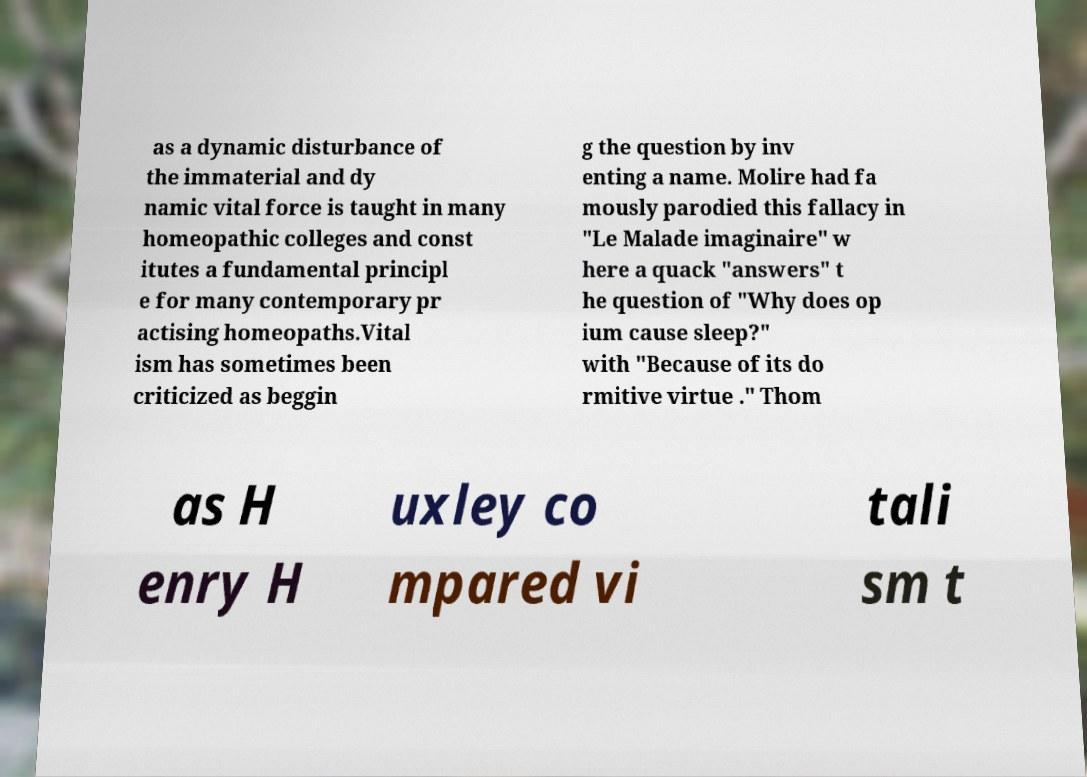Could you extract and type out the text from this image? as a dynamic disturbance of the immaterial and dy namic vital force is taught in many homeopathic colleges and const itutes a fundamental principl e for many contemporary pr actising homeopaths.Vital ism has sometimes been criticized as beggin g the question by inv enting a name. Molire had fa mously parodied this fallacy in "Le Malade imaginaire" w here a quack "answers" t he question of "Why does op ium cause sleep?" with "Because of its do rmitive virtue ." Thom as H enry H uxley co mpared vi tali sm t 